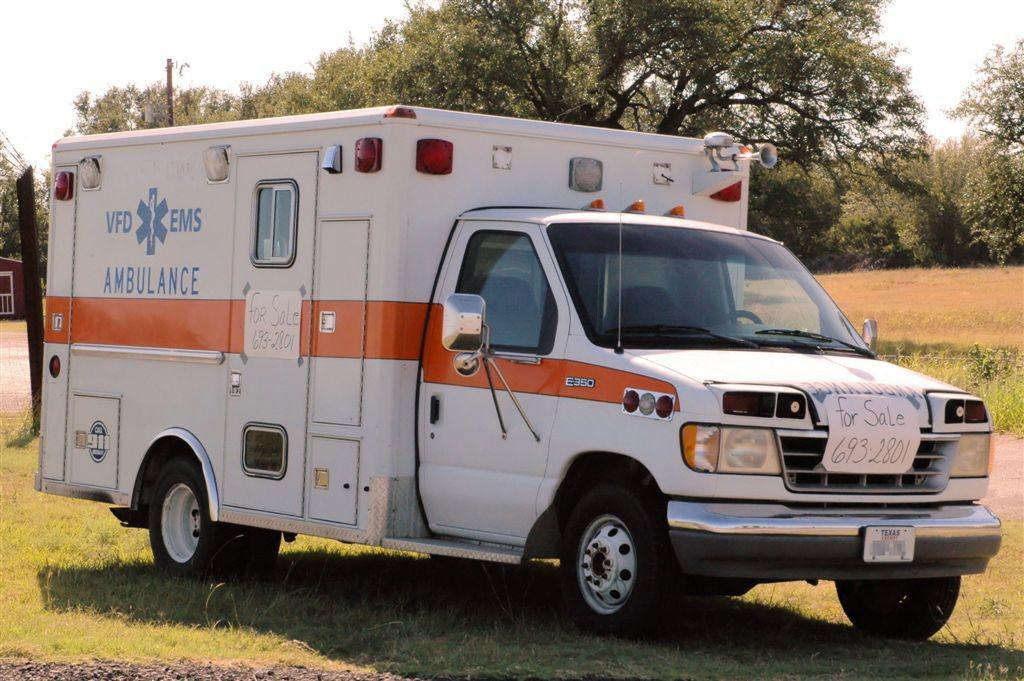<image>
Create a compact narrative representing the image presented. The white and orange vehicle on the grass is an ambulance. 